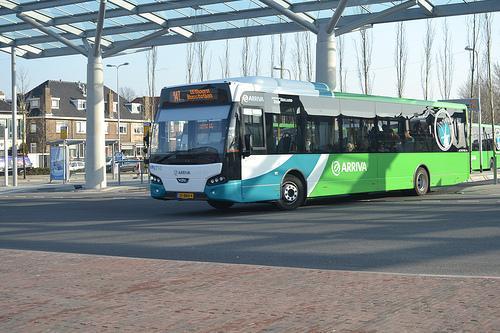How many wheels from the front bus are visible?
Give a very brief answer. 3. 